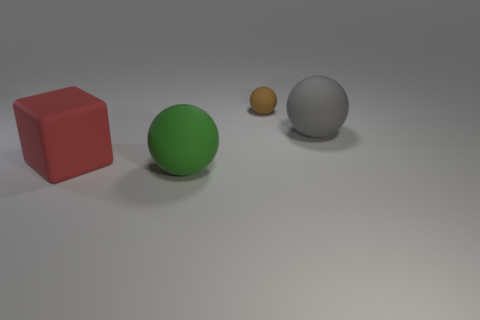Subtract all big balls. How many balls are left? 1 Add 3 large cyan matte blocks. How many objects exist? 7 Subtract all cubes. How many objects are left? 3 Add 4 brown balls. How many brown balls are left? 5 Add 4 large gray spheres. How many large gray spheres exist? 5 Subtract 0 purple cubes. How many objects are left? 4 Subtract all big balls. Subtract all large red rubber blocks. How many objects are left? 1 